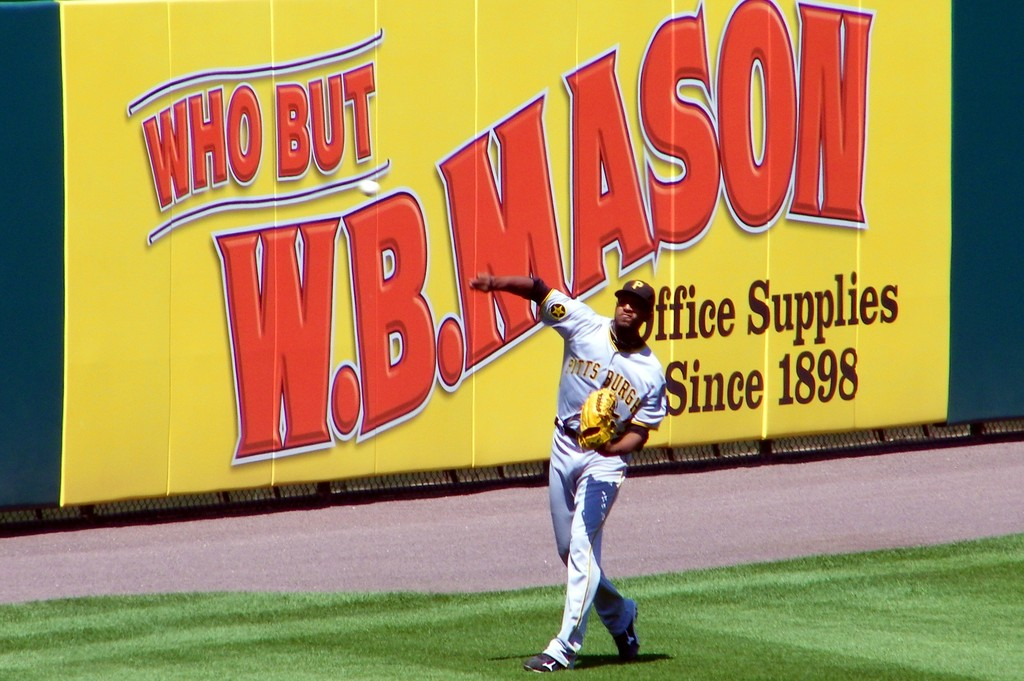Provide a one-sentence caption for the provided image. A Pittsburgh Pirates baseball player, in mid-throw, is captured on the field with a vibrant 'W.B. Mason - Office Supplies Since 1898' advertisement prominently displayed in the background, adding a colorful contrast to the green field. 